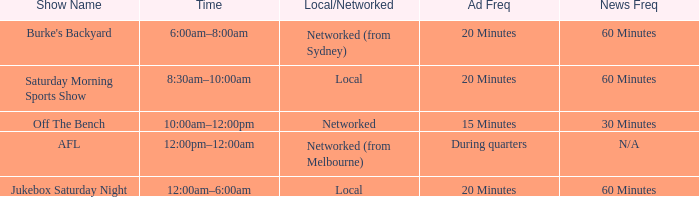What is the local/network with an Ad frequency of 15 minutes? Networked. 